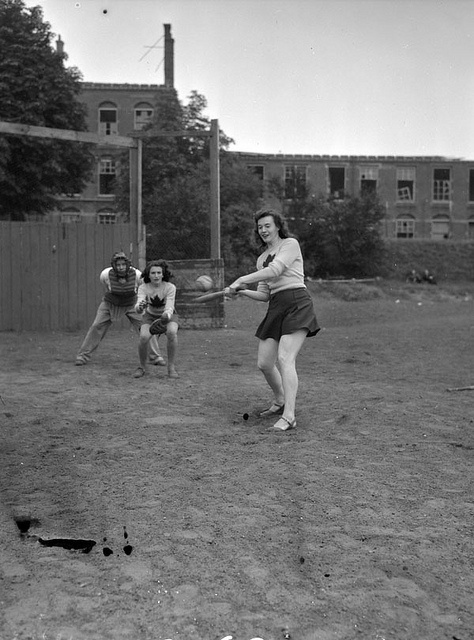Describe the objects in this image and their specific colors. I can see people in gray, darkgray, black, and lightgray tones, people in gray, black, darkgray, and lightgray tones, people in gray, black, and lightgray tones, baseball glove in black and gray tones, and sports ball in gray, darkgray, black, and lightgray tones in this image. 